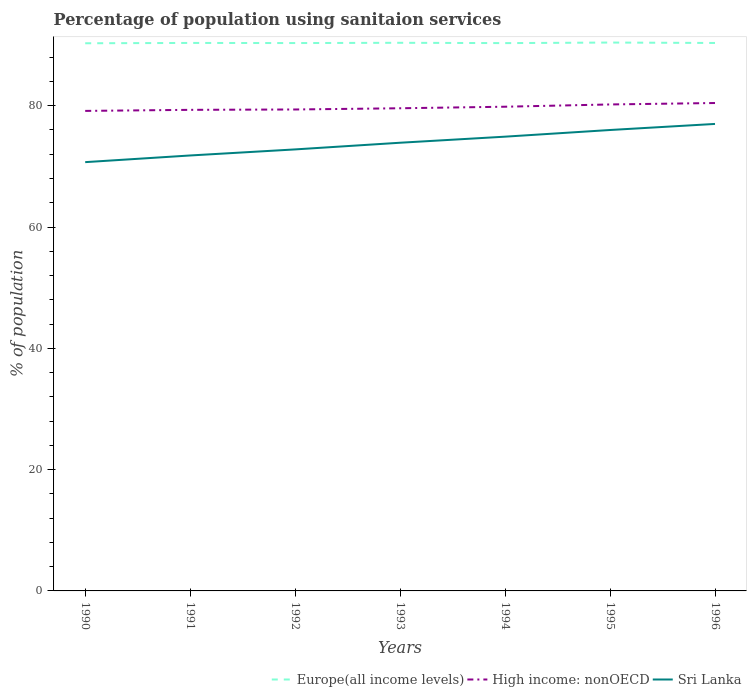How many different coloured lines are there?
Ensure brevity in your answer.  3. Is the number of lines equal to the number of legend labels?
Offer a very short reply. Yes. Across all years, what is the maximum percentage of population using sanitaion services in Sri Lanka?
Make the answer very short. 70.7. What is the total percentage of population using sanitaion services in High income: nonOECD in the graph?
Provide a short and direct response. -0.89. What is the difference between the highest and the second highest percentage of population using sanitaion services in Europe(all income levels)?
Your answer should be very brief. 0.12. Is the percentage of population using sanitaion services in Europe(all income levels) strictly greater than the percentage of population using sanitaion services in Sri Lanka over the years?
Your answer should be compact. No. How many lines are there?
Provide a short and direct response. 3. How many years are there in the graph?
Make the answer very short. 7. Does the graph contain any zero values?
Make the answer very short. No. Where does the legend appear in the graph?
Offer a very short reply. Bottom right. How many legend labels are there?
Ensure brevity in your answer.  3. How are the legend labels stacked?
Provide a succinct answer. Horizontal. What is the title of the graph?
Keep it short and to the point. Percentage of population using sanitaion services. What is the label or title of the Y-axis?
Your answer should be very brief. % of population. What is the % of population of Europe(all income levels) in 1990?
Provide a succinct answer. 90.3. What is the % of population in High income: nonOECD in 1990?
Provide a short and direct response. 79.15. What is the % of population of Sri Lanka in 1990?
Your answer should be compact. 70.7. What is the % of population in Europe(all income levels) in 1991?
Keep it short and to the point. 90.35. What is the % of population of High income: nonOECD in 1991?
Make the answer very short. 79.32. What is the % of population of Sri Lanka in 1991?
Your answer should be very brief. 71.8. What is the % of population of Europe(all income levels) in 1992?
Provide a short and direct response. 90.34. What is the % of population in High income: nonOECD in 1992?
Your response must be concise. 79.38. What is the % of population in Sri Lanka in 1992?
Make the answer very short. 72.8. What is the % of population of Europe(all income levels) in 1993?
Provide a succinct answer. 90.38. What is the % of population of High income: nonOECD in 1993?
Keep it short and to the point. 79.58. What is the % of population of Sri Lanka in 1993?
Your answer should be compact. 73.9. What is the % of population in Europe(all income levels) in 1994?
Your answer should be compact. 90.33. What is the % of population in High income: nonOECD in 1994?
Your response must be concise. 79.84. What is the % of population in Sri Lanka in 1994?
Make the answer very short. 74.9. What is the % of population in Europe(all income levels) in 1995?
Offer a terse response. 90.42. What is the % of population in High income: nonOECD in 1995?
Make the answer very short. 80.21. What is the % of population in Sri Lanka in 1995?
Offer a terse response. 76. What is the % of population in Europe(all income levels) in 1996?
Provide a succinct answer. 90.35. What is the % of population in High income: nonOECD in 1996?
Your response must be concise. 80.45. Across all years, what is the maximum % of population in Europe(all income levels)?
Keep it short and to the point. 90.42. Across all years, what is the maximum % of population of High income: nonOECD?
Your answer should be very brief. 80.45. Across all years, what is the maximum % of population in Sri Lanka?
Offer a terse response. 77. Across all years, what is the minimum % of population of Europe(all income levels)?
Provide a succinct answer. 90.3. Across all years, what is the minimum % of population of High income: nonOECD?
Ensure brevity in your answer.  79.15. Across all years, what is the minimum % of population in Sri Lanka?
Offer a terse response. 70.7. What is the total % of population in Europe(all income levels) in the graph?
Give a very brief answer. 632.46. What is the total % of population in High income: nonOECD in the graph?
Your response must be concise. 557.94. What is the total % of population in Sri Lanka in the graph?
Keep it short and to the point. 517.1. What is the difference between the % of population in Europe(all income levels) in 1990 and that in 1991?
Your response must be concise. -0.05. What is the difference between the % of population in High income: nonOECD in 1990 and that in 1991?
Your response must be concise. -0.18. What is the difference between the % of population of Sri Lanka in 1990 and that in 1991?
Provide a short and direct response. -1.1. What is the difference between the % of population of Europe(all income levels) in 1990 and that in 1992?
Offer a very short reply. -0.03. What is the difference between the % of population in High income: nonOECD in 1990 and that in 1992?
Your response must be concise. -0.23. What is the difference between the % of population of Europe(all income levels) in 1990 and that in 1993?
Make the answer very short. -0.08. What is the difference between the % of population of High income: nonOECD in 1990 and that in 1993?
Your response must be concise. -0.44. What is the difference between the % of population of Europe(all income levels) in 1990 and that in 1994?
Provide a succinct answer. -0.03. What is the difference between the % of population in High income: nonOECD in 1990 and that in 1994?
Provide a succinct answer. -0.69. What is the difference between the % of population in Sri Lanka in 1990 and that in 1994?
Give a very brief answer. -4.2. What is the difference between the % of population in Europe(all income levels) in 1990 and that in 1995?
Offer a very short reply. -0.12. What is the difference between the % of population of High income: nonOECD in 1990 and that in 1995?
Your response must be concise. -1.06. What is the difference between the % of population in Sri Lanka in 1990 and that in 1995?
Give a very brief answer. -5.3. What is the difference between the % of population of Europe(all income levels) in 1990 and that in 1996?
Offer a terse response. -0.05. What is the difference between the % of population of High income: nonOECD in 1990 and that in 1996?
Provide a succinct answer. -1.3. What is the difference between the % of population in Europe(all income levels) in 1991 and that in 1992?
Provide a succinct answer. 0.02. What is the difference between the % of population of High income: nonOECD in 1991 and that in 1992?
Offer a terse response. -0.06. What is the difference between the % of population in Europe(all income levels) in 1991 and that in 1993?
Give a very brief answer. -0.02. What is the difference between the % of population in High income: nonOECD in 1991 and that in 1993?
Your response must be concise. -0.26. What is the difference between the % of population of Sri Lanka in 1991 and that in 1993?
Keep it short and to the point. -2.1. What is the difference between the % of population of Europe(all income levels) in 1991 and that in 1994?
Provide a short and direct response. 0.03. What is the difference between the % of population of High income: nonOECD in 1991 and that in 1994?
Make the answer very short. -0.51. What is the difference between the % of population of Europe(all income levels) in 1991 and that in 1995?
Keep it short and to the point. -0.06. What is the difference between the % of population of High income: nonOECD in 1991 and that in 1995?
Provide a short and direct response. -0.89. What is the difference between the % of population in Europe(all income levels) in 1991 and that in 1996?
Make the answer very short. 0.01. What is the difference between the % of population of High income: nonOECD in 1991 and that in 1996?
Your response must be concise. -1.13. What is the difference between the % of population in Sri Lanka in 1991 and that in 1996?
Offer a very short reply. -5.2. What is the difference between the % of population in Europe(all income levels) in 1992 and that in 1993?
Keep it short and to the point. -0.04. What is the difference between the % of population of High income: nonOECD in 1992 and that in 1993?
Offer a terse response. -0.2. What is the difference between the % of population of Europe(all income levels) in 1992 and that in 1994?
Provide a succinct answer. 0.01. What is the difference between the % of population in High income: nonOECD in 1992 and that in 1994?
Your answer should be compact. -0.46. What is the difference between the % of population of Europe(all income levels) in 1992 and that in 1995?
Your response must be concise. -0.08. What is the difference between the % of population of High income: nonOECD in 1992 and that in 1995?
Your answer should be very brief. -0.83. What is the difference between the % of population in Sri Lanka in 1992 and that in 1995?
Make the answer very short. -3.2. What is the difference between the % of population in Europe(all income levels) in 1992 and that in 1996?
Ensure brevity in your answer.  -0.01. What is the difference between the % of population in High income: nonOECD in 1992 and that in 1996?
Provide a short and direct response. -1.07. What is the difference between the % of population in Europe(all income levels) in 1993 and that in 1994?
Keep it short and to the point. 0.05. What is the difference between the % of population of High income: nonOECD in 1993 and that in 1994?
Your response must be concise. -0.25. What is the difference between the % of population in Sri Lanka in 1993 and that in 1994?
Offer a terse response. -1. What is the difference between the % of population of Europe(all income levels) in 1993 and that in 1995?
Offer a terse response. -0.04. What is the difference between the % of population of High income: nonOECD in 1993 and that in 1995?
Give a very brief answer. -0.63. What is the difference between the % of population of Sri Lanka in 1993 and that in 1995?
Offer a very short reply. -2.1. What is the difference between the % of population in Europe(all income levels) in 1993 and that in 1996?
Make the answer very short. 0.03. What is the difference between the % of population of High income: nonOECD in 1993 and that in 1996?
Provide a short and direct response. -0.87. What is the difference between the % of population in Sri Lanka in 1993 and that in 1996?
Your response must be concise. -3.1. What is the difference between the % of population of Europe(all income levels) in 1994 and that in 1995?
Keep it short and to the point. -0.09. What is the difference between the % of population of High income: nonOECD in 1994 and that in 1995?
Make the answer very short. -0.37. What is the difference between the % of population in Sri Lanka in 1994 and that in 1995?
Offer a very short reply. -1.1. What is the difference between the % of population in Europe(all income levels) in 1994 and that in 1996?
Provide a short and direct response. -0.02. What is the difference between the % of population in High income: nonOECD in 1994 and that in 1996?
Make the answer very short. -0.61. What is the difference between the % of population of Europe(all income levels) in 1995 and that in 1996?
Offer a very short reply. 0.07. What is the difference between the % of population in High income: nonOECD in 1995 and that in 1996?
Provide a short and direct response. -0.24. What is the difference between the % of population in Europe(all income levels) in 1990 and the % of population in High income: nonOECD in 1991?
Make the answer very short. 10.98. What is the difference between the % of population of Europe(all income levels) in 1990 and the % of population of Sri Lanka in 1991?
Your answer should be very brief. 18.5. What is the difference between the % of population in High income: nonOECD in 1990 and the % of population in Sri Lanka in 1991?
Your answer should be very brief. 7.35. What is the difference between the % of population in Europe(all income levels) in 1990 and the % of population in High income: nonOECD in 1992?
Offer a terse response. 10.92. What is the difference between the % of population of Europe(all income levels) in 1990 and the % of population of Sri Lanka in 1992?
Your response must be concise. 17.5. What is the difference between the % of population of High income: nonOECD in 1990 and the % of population of Sri Lanka in 1992?
Your answer should be very brief. 6.35. What is the difference between the % of population in Europe(all income levels) in 1990 and the % of population in High income: nonOECD in 1993?
Your answer should be very brief. 10.72. What is the difference between the % of population in Europe(all income levels) in 1990 and the % of population in Sri Lanka in 1993?
Your response must be concise. 16.4. What is the difference between the % of population in High income: nonOECD in 1990 and the % of population in Sri Lanka in 1993?
Make the answer very short. 5.25. What is the difference between the % of population of Europe(all income levels) in 1990 and the % of population of High income: nonOECD in 1994?
Your response must be concise. 10.46. What is the difference between the % of population of Europe(all income levels) in 1990 and the % of population of Sri Lanka in 1994?
Offer a terse response. 15.4. What is the difference between the % of population in High income: nonOECD in 1990 and the % of population in Sri Lanka in 1994?
Provide a short and direct response. 4.25. What is the difference between the % of population in Europe(all income levels) in 1990 and the % of population in High income: nonOECD in 1995?
Your answer should be very brief. 10.09. What is the difference between the % of population of Europe(all income levels) in 1990 and the % of population of Sri Lanka in 1995?
Your answer should be compact. 14.3. What is the difference between the % of population in High income: nonOECD in 1990 and the % of population in Sri Lanka in 1995?
Offer a terse response. 3.15. What is the difference between the % of population of Europe(all income levels) in 1990 and the % of population of High income: nonOECD in 1996?
Your answer should be compact. 9.85. What is the difference between the % of population in Europe(all income levels) in 1990 and the % of population in Sri Lanka in 1996?
Provide a short and direct response. 13.3. What is the difference between the % of population of High income: nonOECD in 1990 and the % of population of Sri Lanka in 1996?
Give a very brief answer. 2.15. What is the difference between the % of population in Europe(all income levels) in 1991 and the % of population in High income: nonOECD in 1992?
Keep it short and to the point. 10.97. What is the difference between the % of population of Europe(all income levels) in 1991 and the % of population of Sri Lanka in 1992?
Provide a succinct answer. 17.55. What is the difference between the % of population in High income: nonOECD in 1991 and the % of population in Sri Lanka in 1992?
Offer a very short reply. 6.52. What is the difference between the % of population of Europe(all income levels) in 1991 and the % of population of High income: nonOECD in 1993?
Provide a succinct answer. 10.77. What is the difference between the % of population of Europe(all income levels) in 1991 and the % of population of Sri Lanka in 1993?
Your answer should be compact. 16.45. What is the difference between the % of population in High income: nonOECD in 1991 and the % of population in Sri Lanka in 1993?
Your answer should be very brief. 5.42. What is the difference between the % of population of Europe(all income levels) in 1991 and the % of population of High income: nonOECD in 1994?
Your answer should be very brief. 10.52. What is the difference between the % of population of Europe(all income levels) in 1991 and the % of population of Sri Lanka in 1994?
Give a very brief answer. 15.45. What is the difference between the % of population of High income: nonOECD in 1991 and the % of population of Sri Lanka in 1994?
Your answer should be very brief. 4.42. What is the difference between the % of population of Europe(all income levels) in 1991 and the % of population of High income: nonOECD in 1995?
Offer a terse response. 10.14. What is the difference between the % of population in Europe(all income levels) in 1991 and the % of population in Sri Lanka in 1995?
Provide a succinct answer. 14.35. What is the difference between the % of population in High income: nonOECD in 1991 and the % of population in Sri Lanka in 1995?
Make the answer very short. 3.32. What is the difference between the % of population of Europe(all income levels) in 1991 and the % of population of High income: nonOECD in 1996?
Your response must be concise. 9.9. What is the difference between the % of population of Europe(all income levels) in 1991 and the % of population of Sri Lanka in 1996?
Your response must be concise. 13.35. What is the difference between the % of population of High income: nonOECD in 1991 and the % of population of Sri Lanka in 1996?
Provide a succinct answer. 2.32. What is the difference between the % of population in Europe(all income levels) in 1992 and the % of population in High income: nonOECD in 1993?
Your answer should be very brief. 10.75. What is the difference between the % of population in Europe(all income levels) in 1992 and the % of population in Sri Lanka in 1993?
Your answer should be very brief. 16.44. What is the difference between the % of population of High income: nonOECD in 1992 and the % of population of Sri Lanka in 1993?
Provide a succinct answer. 5.48. What is the difference between the % of population of Europe(all income levels) in 1992 and the % of population of High income: nonOECD in 1994?
Ensure brevity in your answer.  10.5. What is the difference between the % of population in Europe(all income levels) in 1992 and the % of population in Sri Lanka in 1994?
Make the answer very short. 15.44. What is the difference between the % of population in High income: nonOECD in 1992 and the % of population in Sri Lanka in 1994?
Your response must be concise. 4.48. What is the difference between the % of population in Europe(all income levels) in 1992 and the % of population in High income: nonOECD in 1995?
Give a very brief answer. 10.12. What is the difference between the % of population of Europe(all income levels) in 1992 and the % of population of Sri Lanka in 1995?
Provide a succinct answer. 14.34. What is the difference between the % of population in High income: nonOECD in 1992 and the % of population in Sri Lanka in 1995?
Offer a very short reply. 3.38. What is the difference between the % of population of Europe(all income levels) in 1992 and the % of population of High income: nonOECD in 1996?
Your response must be concise. 9.89. What is the difference between the % of population of Europe(all income levels) in 1992 and the % of population of Sri Lanka in 1996?
Your response must be concise. 13.34. What is the difference between the % of population of High income: nonOECD in 1992 and the % of population of Sri Lanka in 1996?
Your response must be concise. 2.38. What is the difference between the % of population of Europe(all income levels) in 1993 and the % of population of High income: nonOECD in 1994?
Offer a terse response. 10.54. What is the difference between the % of population in Europe(all income levels) in 1993 and the % of population in Sri Lanka in 1994?
Your answer should be very brief. 15.48. What is the difference between the % of population of High income: nonOECD in 1993 and the % of population of Sri Lanka in 1994?
Provide a succinct answer. 4.68. What is the difference between the % of population of Europe(all income levels) in 1993 and the % of population of High income: nonOECD in 1995?
Provide a succinct answer. 10.17. What is the difference between the % of population of Europe(all income levels) in 1993 and the % of population of Sri Lanka in 1995?
Keep it short and to the point. 14.38. What is the difference between the % of population of High income: nonOECD in 1993 and the % of population of Sri Lanka in 1995?
Ensure brevity in your answer.  3.58. What is the difference between the % of population in Europe(all income levels) in 1993 and the % of population in High income: nonOECD in 1996?
Provide a succinct answer. 9.93. What is the difference between the % of population in Europe(all income levels) in 1993 and the % of population in Sri Lanka in 1996?
Make the answer very short. 13.38. What is the difference between the % of population in High income: nonOECD in 1993 and the % of population in Sri Lanka in 1996?
Provide a succinct answer. 2.58. What is the difference between the % of population of Europe(all income levels) in 1994 and the % of population of High income: nonOECD in 1995?
Keep it short and to the point. 10.12. What is the difference between the % of population in Europe(all income levels) in 1994 and the % of population in Sri Lanka in 1995?
Provide a short and direct response. 14.33. What is the difference between the % of population of High income: nonOECD in 1994 and the % of population of Sri Lanka in 1995?
Your answer should be very brief. 3.84. What is the difference between the % of population in Europe(all income levels) in 1994 and the % of population in High income: nonOECD in 1996?
Your answer should be very brief. 9.88. What is the difference between the % of population of Europe(all income levels) in 1994 and the % of population of Sri Lanka in 1996?
Make the answer very short. 13.33. What is the difference between the % of population in High income: nonOECD in 1994 and the % of population in Sri Lanka in 1996?
Your answer should be very brief. 2.84. What is the difference between the % of population of Europe(all income levels) in 1995 and the % of population of High income: nonOECD in 1996?
Provide a short and direct response. 9.97. What is the difference between the % of population in Europe(all income levels) in 1995 and the % of population in Sri Lanka in 1996?
Keep it short and to the point. 13.42. What is the difference between the % of population in High income: nonOECD in 1995 and the % of population in Sri Lanka in 1996?
Provide a succinct answer. 3.21. What is the average % of population in Europe(all income levels) per year?
Make the answer very short. 90.35. What is the average % of population of High income: nonOECD per year?
Your answer should be very brief. 79.71. What is the average % of population in Sri Lanka per year?
Offer a terse response. 73.87. In the year 1990, what is the difference between the % of population in Europe(all income levels) and % of population in High income: nonOECD?
Provide a short and direct response. 11.15. In the year 1990, what is the difference between the % of population of Europe(all income levels) and % of population of Sri Lanka?
Ensure brevity in your answer.  19.6. In the year 1990, what is the difference between the % of population in High income: nonOECD and % of population in Sri Lanka?
Offer a very short reply. 8.45. In the year 1991, what is the difference between the % of population in Europe(all income levels) and % of population in High income: nonOECD?
Your answer should be compact. 11.03. In the year 1991, what is the difference between the % of population in Europe(all income levels) and % of population in Sri Lanka?
Ensure brevity in your answer.  18.55. In the year 1991, what is the difference between the % of population in High income: nonOECD and % of population in Sri Lanka?
Make the answer very short. 7.52. In the year 1992, what is the difference between the % of population in Europe(all income levels) and % of population in High income: nonOECD?
Ensure brevity in your answer.  10.95. In the year 1992, what is the difference between the % of population in Europe(all income levels) and % of population in Sri Lanka?
Provide a succinct answer. 17.54. In the year 1992, what is the difference between the % of population in High income: nonOECD and % of population in Sri Lanka?
Provide a short and direct response. 6.58. In the year 1993, what is the difference between the % of population in Europe(all income levels) and % of population in High income: nonOECD?
Provide a succinct answer. 10.79. In the year 1993, what is the difference between the % of population in Europe(all income levels) and % of population in Sri Lanka?
Your answer should be very brief. 16.48. In the year 1993, what is the difference between the % of population in High income: nonOECD and % of population in Sri Lanka?
Make the answer very short. 5.68. In the year 1994, what is the difference between the % of population in Europe(all income levels) and % of population in High income: nonOECD?
Your response must be concise. 10.49. In the year 1994, what is the difference between the % of population of Europe(all income levels) and % of population of Sri Lanka?
Provide a succinct answer. 15.43. In the year 1994, what is the difference between the % of population of High income: nonOECD and % of population of Sri Lanka?
Provide a short and direct response. 4.94. In the year 1995, what is the difference between the % of population in Europe(all income levels) and % of population in High income: nonOECD?
Your answer should be compact. 10.21. In the year 1995, what is the difference between the % of population in Europe(all income levels) and % of population in Sri Lanka?
Your response must be concise. 14.42. In the year 1995, what is the difference between the % of population of High income: nonOECD and % of population of Sri Lanka?
Ensure brevity in your answer.  4.21. In the year 1996, what is the difference between the % of population in Europe(all income levels) and % of population in High income: nonOECD?
Provide a succinct answer. 9.9. In the year 1996, what is the difference between the % of population of Europe(all income levels) and % of population of Sri Lanka?
Give a very brief answer. 13.35. In the year 1996, what is the difference between the % of population in High income: nonOECD and % of population in Sri Lanka?
Provide a short and direct response. 3.45. What is the ratio of the % of population in Europe(all income levels) in 1990 to that in 1991?
Give a very brief answer. 1. What is the ratio of the % of population in Sri Lanka in 1990 to that in 1991?
Give a very brief answer. 0.98. What is the ratio of the % of population in High income: nonOECD in 1990 to that in 1992?
Give a very brief answer. 1. What is the ratio of the % of population in Sri Lanka in 1990 to that in 1992?
Ensure brevity in your answer.  0.97. What is the ratio of the % of population in Sri Lanka in 1990 to that in 1993?
Your response must be concise. 0.96. What is the ratio of the % of population of Sri Lanka in 1990 to that in 1994?
Offer a terse response. 0.94. What is the ratio of the % of population in High income: nonOECD in 1990 to that in 1995?
Provide a short and direct response. 0.99. What is the ratio of the % of population of Sri Lanka in 1990 to that in 1995?
Provide a short and direct response. 0.93. What is the ratio of the % of population in High income: nonOECD in 1990 to that in 1996?
Keep it short and to the point. 0.98. What is the ratio of the % of population in Sri Lanka in 1990 to that in 1996?
Provide a short and direct response. 0.92. What is the ratio of the % of population of Sri Lanka in 1991 to that in 1992?
Offer a very short reply. 0.99. What is the ratio of the % of population of Sri Lanka in 1991 to that in 1993?
Provide a short and direct response. 0.97. What is the ratio of the % of population of Europe(all income levels) in 1991 to that in 1994?
Offer a terse response. 1. What is the ratio of the % of population of High income: nonOECD in 1991 to that in 1994?
Offer a very short reply. 0.99. What is the ratio of the % of population of Sri Lanka in 1991 to that in 1994?
Provide a short and direct response. 0.96. What is the ratio of the % of population of Europe(all income levels) in 1991 to that in 1995?
Offer a very short reply. 1. What is the ratio of the % of population of High income: nonOECD in 1991 to that in 1995?
Your answer should be compact. 0.99. What is the ratio of the % of population of Sri Lanka in 1991 to that in 1995?
Offer a terse response. 0.94. What is the ratio of the % of population in High income: nonOECD in 1991 to that in 1996?
Provide a short and direct response. 0.99. What is the ratio of the % of population in Sri Lanka in 1991 to that in 1996?
Ensure brevity in your answer.  0.93. What is the ratio of the % of population of High income: nonOECD in 1992 to that in 1993?
Ensure brevity in your answer.  1. What is the ratio of the % of population of Sri Lanka in 1992 to that in 1993?
Provide a short and direct response. 0.99. What is the ratio of the % of population of High income: nonOECD in 1992 to that in 1994?
Offer a very short reply. 0.99. What is the ratio of the % of population in High income: nonOECD in 1992 to that in 1995?
Your answer should be compact. 0.99. What is the ratio of the % of population in Sri Lanka in 1992 to that in 1995?
Provide a succinct answer. 0.96. What is the ratio of the % of population in High income: nonOECD in 1992 to that in 1996?
Make the answer very short. 0.99. What is the ratio of the % of population in Sri Lanka in 1992 to that in 1996?
Your answer should be very brief. 0.95. What is the ratio of the % of population in Europe(all income levels) in 1993 to that in 1994?
Make the answer very short. 1. What is the ratio of the % of population of Sri Lanka in 1993 to that in 1994?
Provide a short and direct response. 0.99. What is the ratio of the % of population of High income: nonOECD in 1993 to that in 1995?
Your response must be concise. 0.99. What is the ratio of the % of population of Sri Lanka in 1993 to that in 1995?
Offer a terse response. 0.97. What is the ratio of the % of population of Europe(all income levels) in 1993 to that in 1996?
Your answer should be very brief. 1. What is the ratio of the % of population of High income: nonOECD in 1993 to that in 1996?
Provide a succinct answer. 0.99. What is the ratio of the % of population of Sri Lanka in 1993 to that in 1996?
Your answer should be very brief. 0.96. What is the ratio of the % of population of High income: nonOECD in 1994 to that in 1995?
Give a very brief answer. 1. What is the ratio of the % of population of Sri Lanka in 1994 to that in 1995?
Offer a terse response. 0.99. What is the ratio of the % of population in Europe(all income levels) in 1994 to that in 1996?
Make the answer very short. 1. What is the ratio of the % of population in High income: nonOECD in 1994 to that in 1996?
Keep it short and to the point. 0.99. What is the ratio of the % of population in Sri Lanka in 1994 to that in 1996?
Provide a short and direct response. 0.97. What is the ratio of the % of population in Europe(all income levels) in 1995 to that in 1996?
Provide a succinct answer. 1. What is the difference between the highest and the second highest % of population in Europe(all income levels)?
Your answer should be compact. 0.04. What is the difference between the highest and the second highest % of population in High income: nonOECD?
Your response must be concise. 0.24. What is the difference between the highest and the second highest % of population of Sri Lanka?
Provide a short and direct response. 1. What is the difference between the highest and the lowest % of population of Europe(all income levels)?
Ensure brevity in your answer.  0.12. What is the difference between the highest and the lowest % of population in High income: nonOECD?
Your answer should be compact. 1.3. What is the difference between the highest and the lowest % of population in Sri Lanka?
Keep it short and to the point. 6.3. 